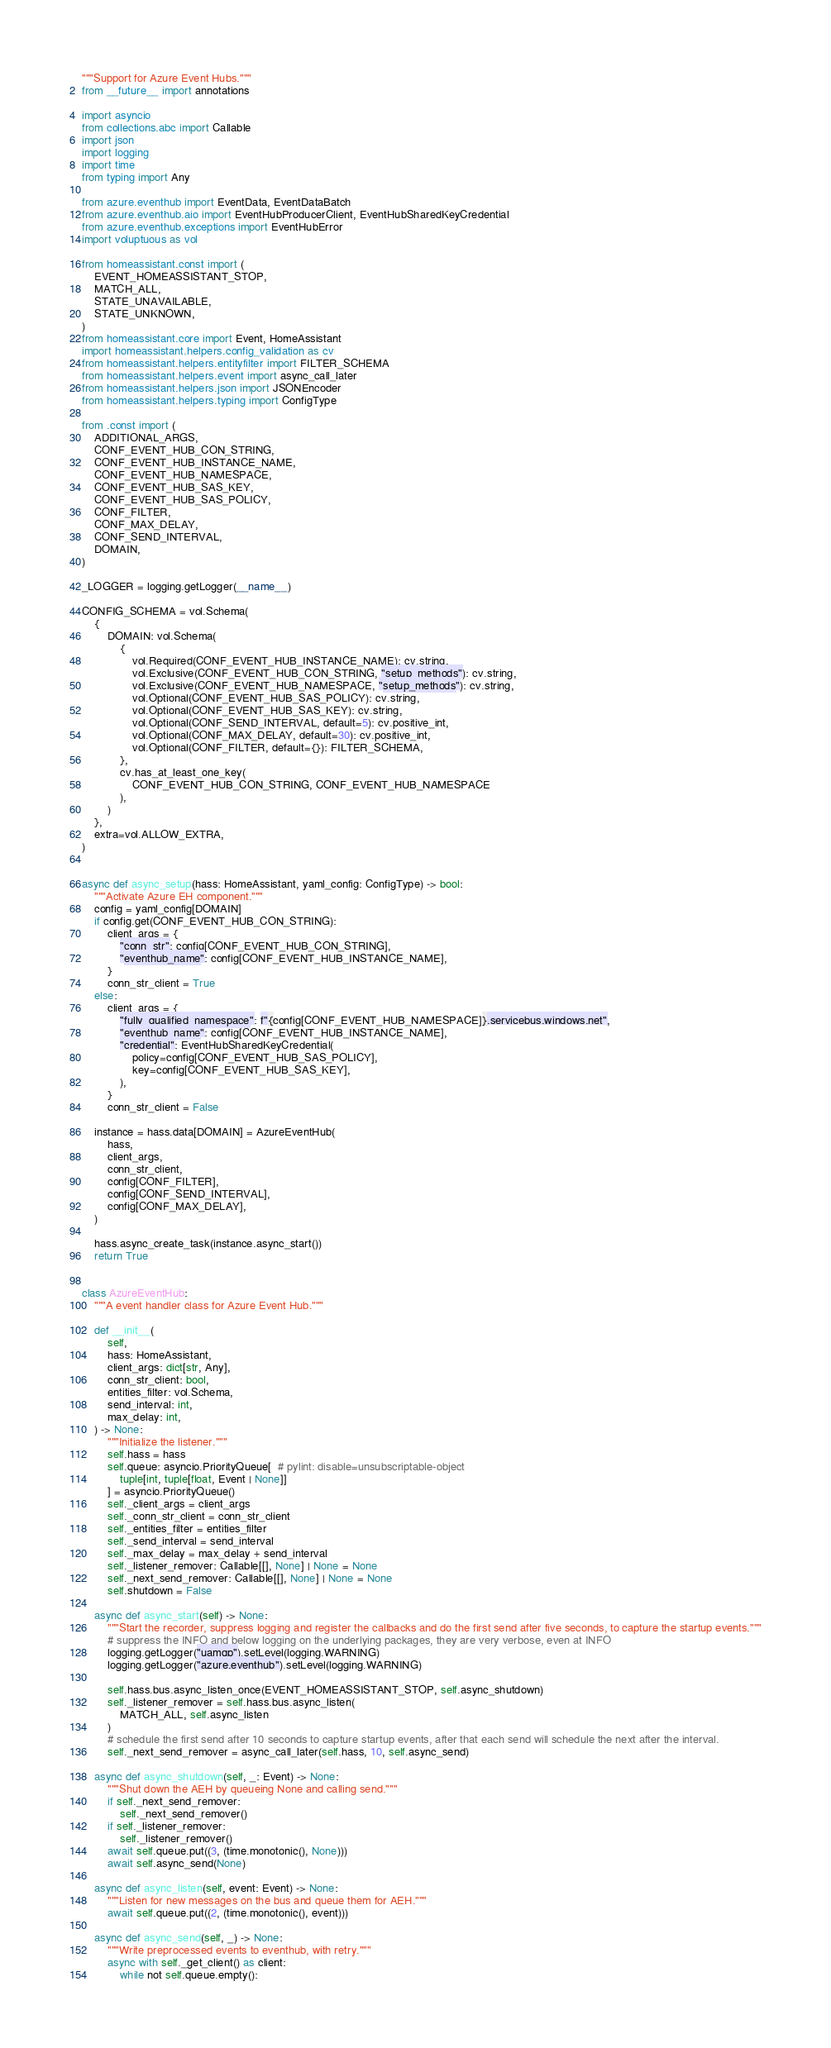<code> <loc_0><loc_0><loc_500><loc_500><_Python_>"""Support for Azure Event Hubs."""
from __future__ import annotations

import asyncio
from collections.abc import Callable
import json
import logging
import time
from typing import Any

from azure.eventhub import EventData, EventDataBatch
from azure.eventhub.aio import EventHubProducerClient, EventHubSharedKeyCredential
from azure.eventhub.exceptions import EventHubError
import voluptuous as vol

from homeassistant.const import (
    EVENT_HOMEASSISTANT_STOP,
    MATCH_ALL,
    STATE_UNAVAILABLE,
    STATE_UNKNOWN,
)
from homeassistant.core import Event, HomeAssistant
import homeassistant.helpers.config_validation as cv
from homeassistant.helpers.entityfilter import FILTER_SCHEMA
from homeassistant.helpers.event import async_call_later
from homeassistant.helpers.json import JSONEncoder
from homeassistant.helpers.typing import ConfigType

from .const import (
    ADDITIONAL_ARGS,
    CONF_EVENT_HUB_CON_STRING,
    CONF_EVENT_HUB_INSTANCE_NAME,
    CONF_EVENT_HUB_NAMESPACE,
    CONF_EVENT_HUB_SAS_KEY,
    CONF_EVENT_HUB_SAS_POLICY,
    CONF_FILTER,
    CONF_MAX_DELAY,
    CONF_SEND_INTERVAL,
    DOMAIN,
)

_LOGGER = logging.getLogger(__name__)

CONFIG_SCHEMA = vol.Schema(
    {
        DOMAIN: vol.Schema(
            {
                vol.Required(CONF_EVENT_HUB_INSTANCE_NAME): cv.string,
                vol.Exclusive(CONF_EVENT_HUB_CON_STRING, "setup_methods"): cv.string,
                vol.Exclusive(CONF_EVENT_HUB_NAMESPACE, "setup_methods"): cv.string,
                vol.Optional(CONF_EVENT_HUB_SAS_POLICY): cv.string,
                vol.Optional(CONF_EVENT_HUB_SAS_KEY): cv.string,
                vol.Optional(CONF_SEND_INTERVAL, default=5): cv.positive_int,
                vol.Optional(CONF_MAX_DELAY, default=30): cv.positive_int,
                vol.Optional(CONF_FILTER, default={}): FILTER_SCHEMA,
            },
            cv.has_at_least_one_key(
                CONF_EVENT_HUB_CON_STRING, CONF_EVENT_HUB_NAMESPACE
            ),
        )
    },
    extra=vol.ALLOW_EXTRA,
)


async def async_setup(hass: HomeAssistant, yaml_config: ConfigType) -> bool:
    """Activate Azure EH component."""
    config = yaml_config[DOMAIN]
    if config.get(CONF_EVENT_HUB_CON_STRING):
        client_args = {
            "conn_str": config[CONF_EVENT_HUB_CON_STRING],
            "eventhub_name": config[CONF_EVENT_HUB_INSTANCE_NAME],
        }
        conn_str_client = True
    else:
        client_args = {
            "fully_qualified_namespace": f"{config[CONF_EVENT_HUB_NAMESPACE]}.servicebus.windows.net",
            "eventhub_name": config[CONF_EVENT_HUB_INSTANCE_NAME],
            "credential": EventHubSharedKeyCredential(
                policy=config[CONF_EVENT_HUB_SAS_POLICY],
                key=config[CONF_EVENT_HUB_SAS_KEY],
            ),
        }
        conn_str_client = False

    instance = hass.data[DOMAIN] = AzureEventHub(
        hass,
        client_args,
        conn_str_client,
        config[CONF_FILTER],
        config[CONF_SEND_INTERVAL],
        config[CONF_MAX_DELAY],
    )

    hass.async_create_task(instance.async_start())
    return True


class AzureEventHub:
    """A event handler class for Azure Event Hub."""

    def __init__(
        self,
        hass: HomeAssistant,
        client_args: dict[str, Any],
        conn_str_client: bool,
        entities_filter: vol.Schema,
        send_interval: int,
        max_delay: int,
    ) -> None:
        """Initialize the listener."""
        self.hass = hass
        self.queue: asyncio.PriorityQueue[  # pylint: disable=unsubscriptable-object
            tuple[int, tuple[float, Event | None]]
        ] = asyncio.PriorityQueue()
        self._client_args = client_args
        self._conn_str_client = conn_str_client
        self._entities_filter = entities_filter
        self._send_interval = send_interval
        self._max_delay = max_delay + send_interval
        self._listener_remover: Callable[[], None] | None = None
        self._next_send_remover: Callable[[], None] | None = None
        self.shutdown = False

    async def async_start(self) -> None:
        """Start the recorder, suppress logging and register the callbacks and do the first send after five seconds, to capture the startup events."""
        # suppress the INFO and below logging on the underlying packages, they are very verbose, even at INFO
        logging.getLogger("uamqp").setLevel(logging.WARNING)
        logging.getLogger("azure.eventhub").setLevel(logging.WARNING)

        self.hass.bus.async_listen_once(EVENT_HOMEASSISTANT_STOP, self.async_shutdown)
        self._listener_remover = self.hass.bus.async_listen(
            MATCH_ALL, self.async_listen
        )
        # schedule the first send after 10 seconds to capture startup events, after that each send will schedule the next after the interval.
        self._next_send_remover = async_call_later(self.hass, 10, self.async_send)

    async def async_shutdown(self, _: Event) -> None:
        """Shut down the AEH by queueing None and calling send."""
        if self._next_send_remover:
            self._next_send_remover()
        if self._listener_remover:
            self._listener_remover()
        await self.queue.put((3, (time.monotonic(), None)))
        await self.async_send(None)

    async def async_listen(self, event: Event) -> None:
        """Listen for new messages on the bus and queue them for AEH."""
        await self.queue.put((2, (time.monotonic(), event)))

    async def async_send(self, _) -> None:
        """Write preprocessed events to eventhub, with retry."""
        async with self._get_client() as client:
            while not self.queue.empty():</code> 